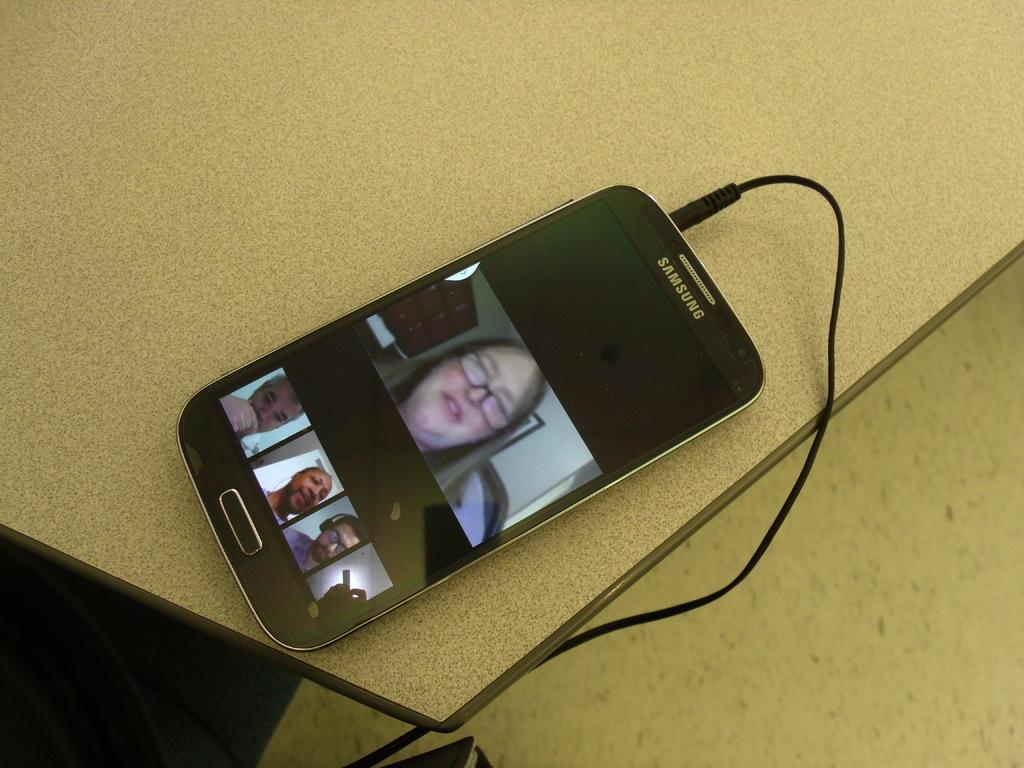<image>
Offer a succinct explanation of the picture presented. A plugged in Samsung smartphone shows video chat widows. 